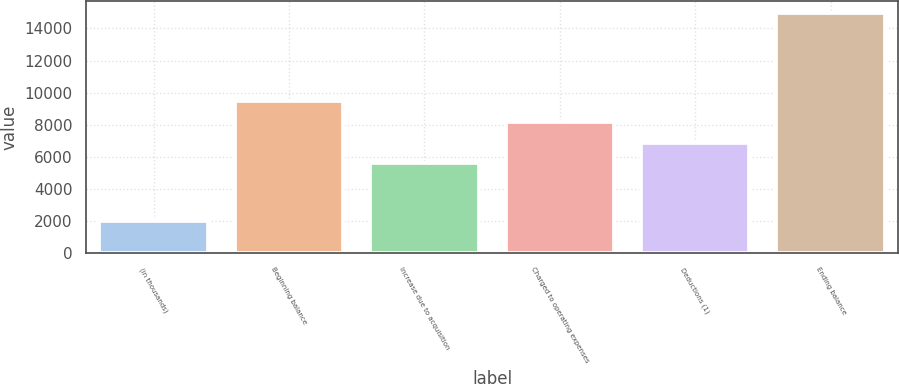Convert chart. <chart><loc_0><loc_0><loc_500><loc_500><bar_chart><fcel>(in thousands)<fcel>Beginning balance<fcel>Increase due to acquisition<fcel>Charged to operating expenses<fcel>Deductions (1)<fcel>Ending balance<nl><fcel>2018<fcel>9490.9<fcel>5602<fcel>8194.6<fcel>6898.3<fcel>14981<nl></chart> 